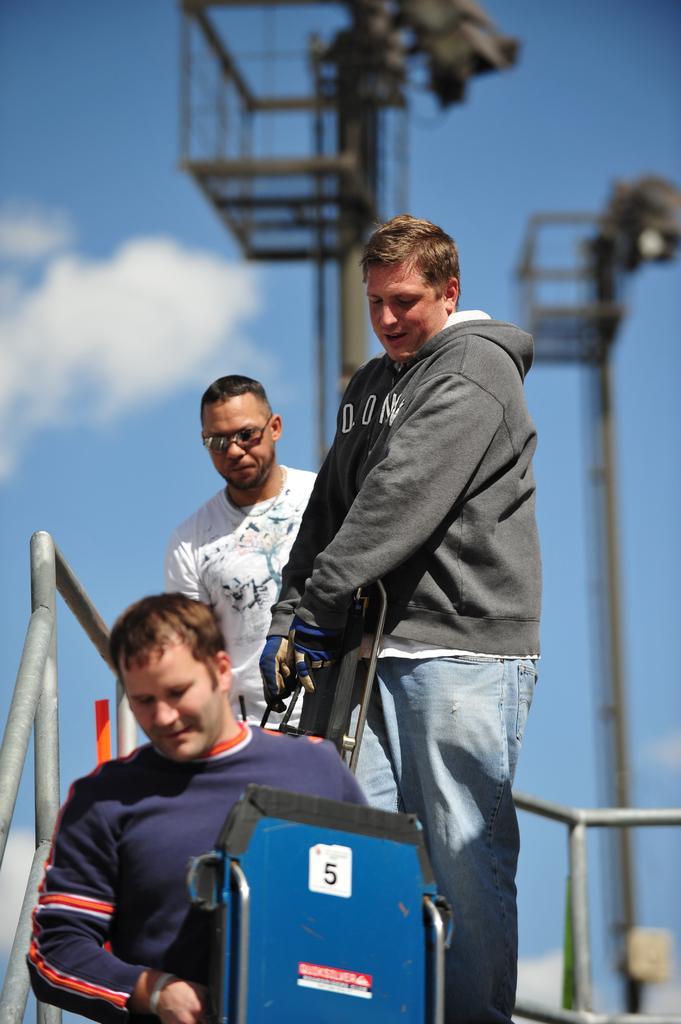Can you describe this image briefly? In this picture there is man wearing white color t- shirt standing on the bridge. In the front there is a boy wearing red color t-shirt holding a blue color trolley. Behind we can see the iron pole and hanging lift. 